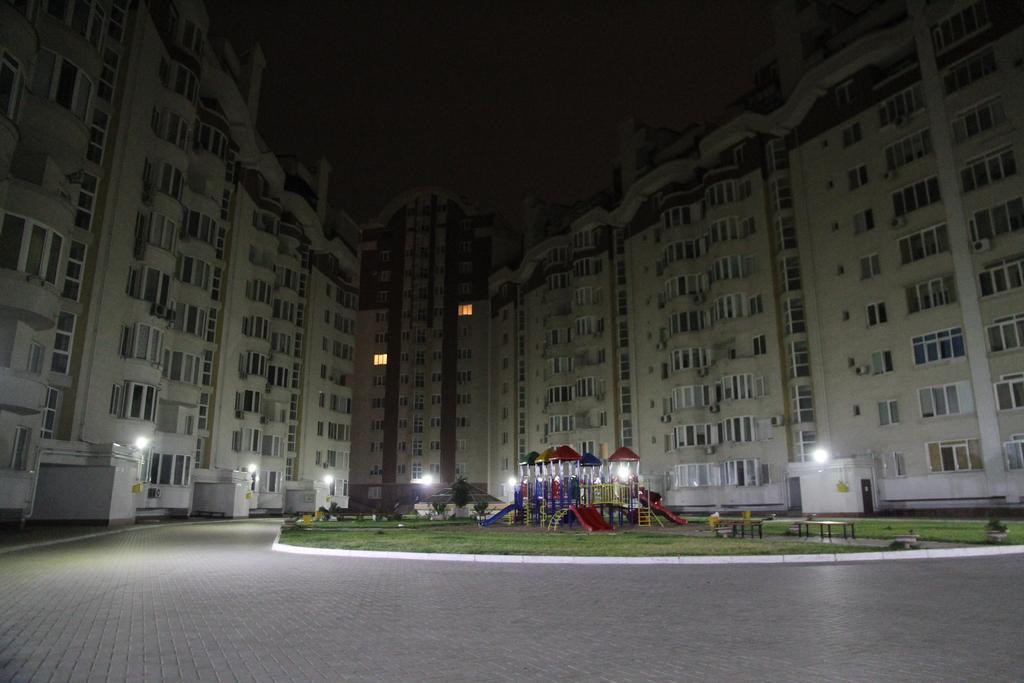Could you give a brief overview of what you see in this image? In this image we can see there are so many buildings. In the middle of the buildings there is a path and ground. In the ground there are sliders, plants, benches. In the background of the image there is a sky. 